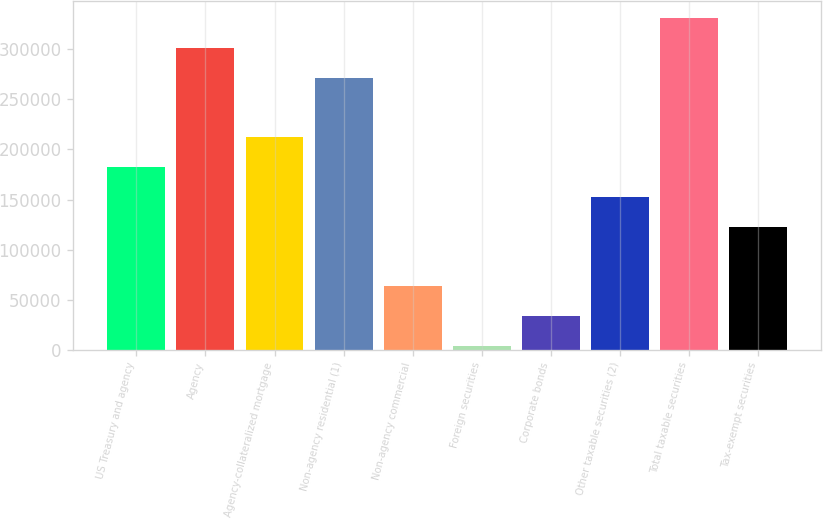<chart> <loc_0><loc_0><loc_500><loc_500><bar_chart><fcel>US Treasury and agency<fcel>Agency<fcel>Agency-collateralized mortgage<fcel>Non-agency residential (1)<fcel>Non-agency commercial<fcel>Foreign securities<fcel>Corporate bonds<fcel>Other taxable securities (2)<fcel>Total taxable securities<fcel>Tax-exempt securities<nl><fcel>182519<fcel>301601<fcel>212290<fcel>271831<fcel>63437.8<fcel>3897<fcel>33667.4<fcel>152749<fcel>331371<fcel>122979<nl></chart> 